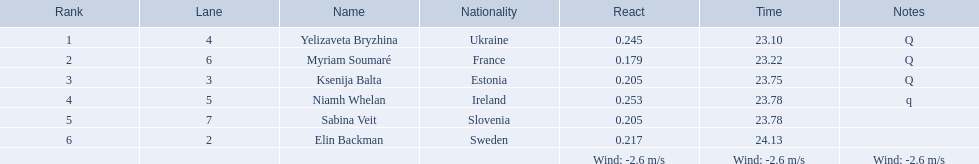Which athlete is from sweden? Elin Backman. What was their time to finish the race? 24.13. 